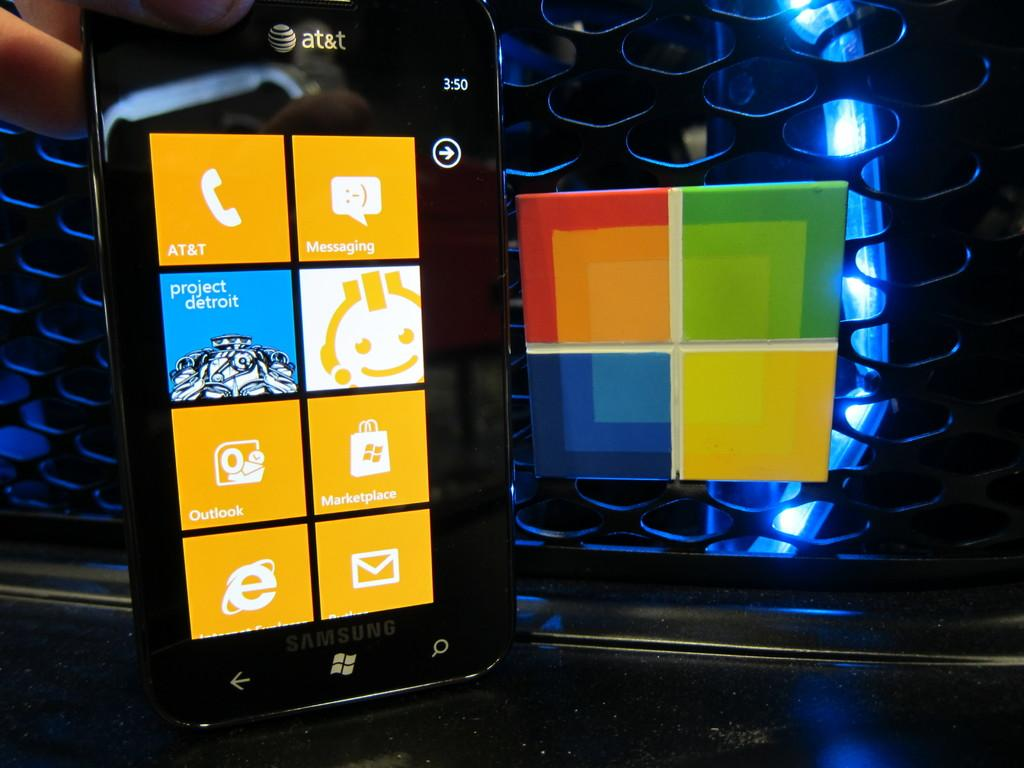Provide a one-sentence caption for the provided image. A smart phone with a project detroit app on it. 